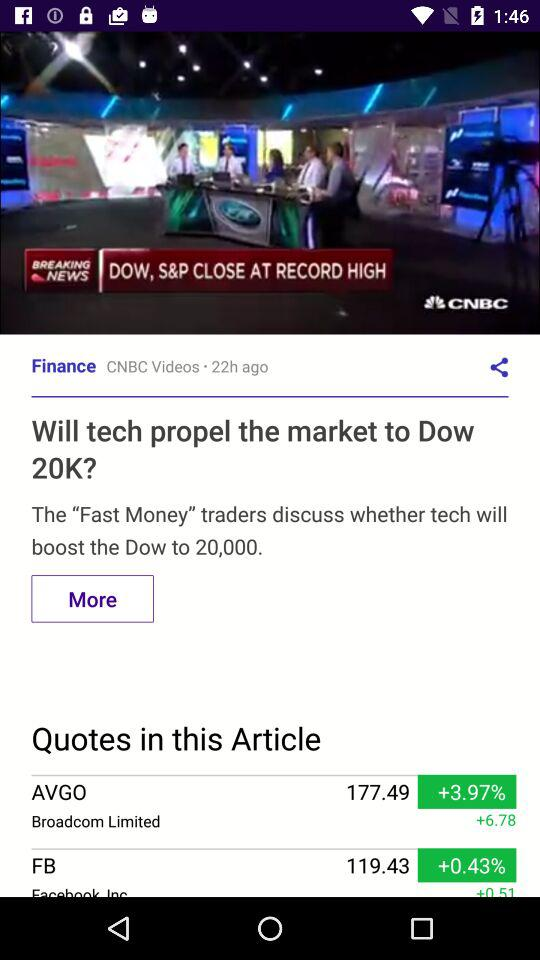When was the article related to finance posted? The article related to finance was posted 22 hours ago. 